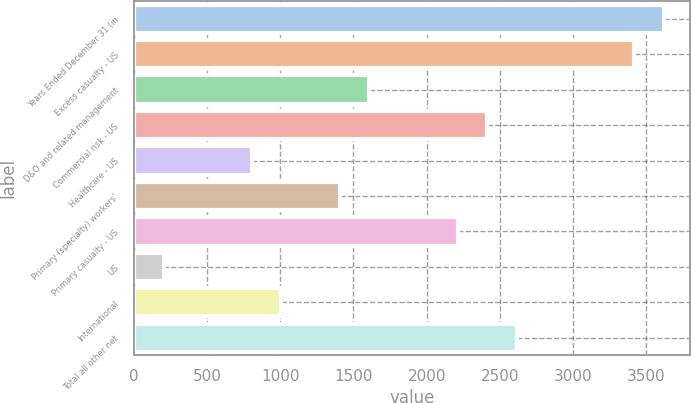<chart> <loc_0><loc_0><loc_500><loc_500><bar_chart><fcel>Years Ended December 31 (in<fcel>Excess casualty - US<fcel>D&O and related management<fcel>Commercial risk - US<fcel>Healthcare - US<fcel>Primary (specialty) workers'<fcel>Primary casualty - US<fcel>US<fcel>International<fcel>Total all other net<nl><fcel>3618.2<fcel>3417.3<fcel>1609.2<fcel>2412.8<fcel>805.6<fcel>1408.3<fcel>2211.9<fcel>202.9<fcel>1006.5<fcel>2613.7<nl></chart> 